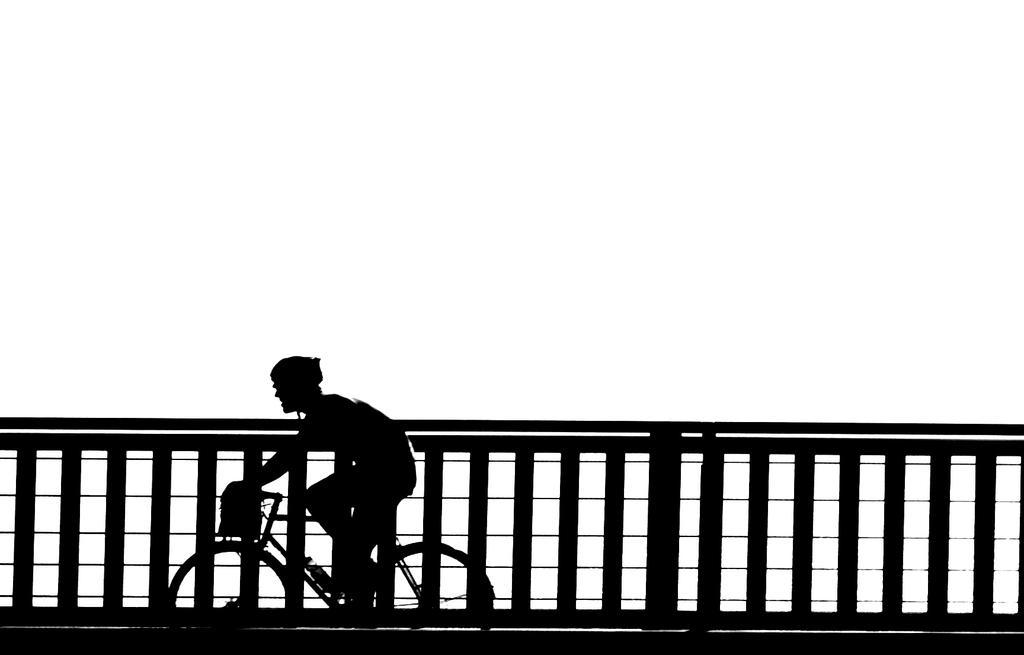In one or two sentences, can you explain what this image depicts? The person is riding a bicycle and there is a fence beside him. 